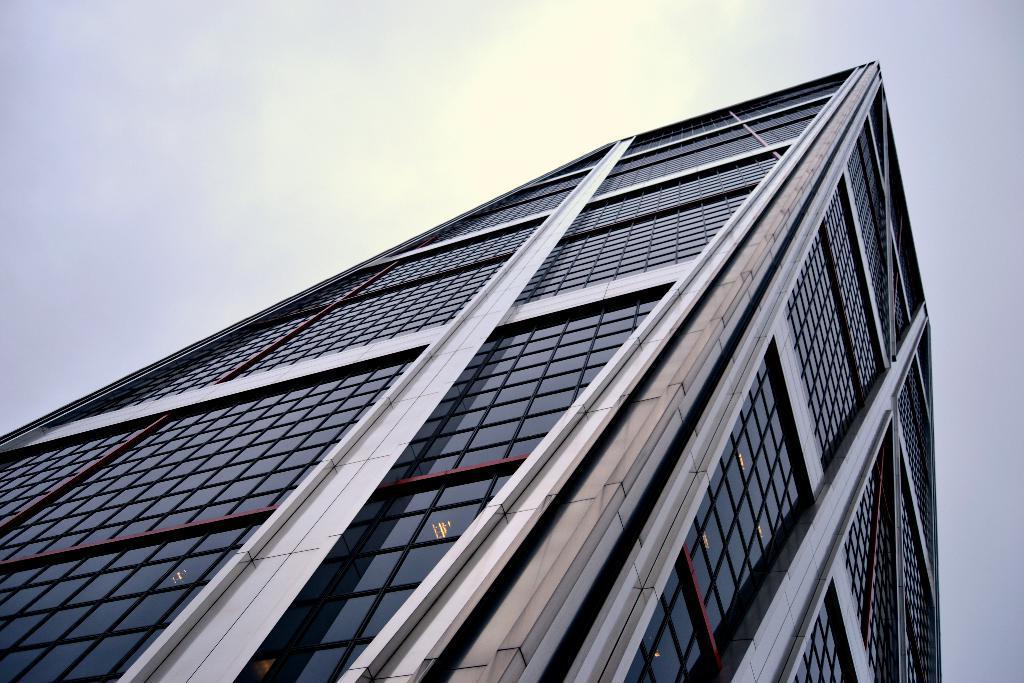In one or two sentences, can you explain what this image depicts? In this image we can see a building and glass doors. In the background we can see the sun in the sky. 